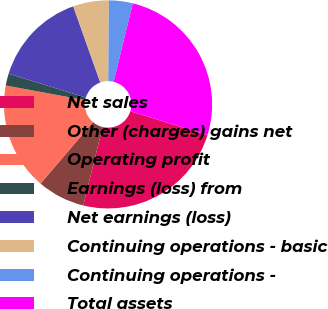Convert chart to OTSL. <chart><loc_0><loc_0><loc_500><loc_500><pie_chart><fcel>Net sales<fcel>Other (charges) gains net<fcel>Operating profit<fcel>Earnings (loss) from<fcel>Net earnings (loss)<fcel>Continuing operations - basic<fcel>Continuing operations -<fcel>Total assets<nl><fcel>24.07%<fcel>7.41%<fcel>16.67%<fcel>1.85%<fcel>14.81%<fcel>5.56%<fcel>3.7%<fcel>25.93%<nl></chart> 